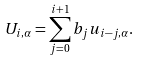<formula> <loc_0><loc_0><loc_500><loc_500>U _ { i , \alpha } = \sum _ { j = 0 } ^ { i + 1 } b _ { j } u _ { i - j , \alpha } .</formula> 